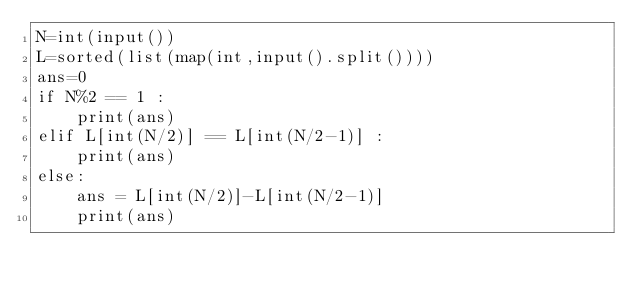Convert code to text. <code><loc_0><loc_0><loc_500><loc_500><_Python_>N=int(input())
L=sorted(list(map(int,input().split())))
ans=0
if N%2 == 1 :
    print(ans)
elif L[int(N/2)] == L[int(N/2-1)] :
    print(ans)
else:
    ans = L[int(N/2)]-L[int(N/2-1)]
    print(ans)</code> 